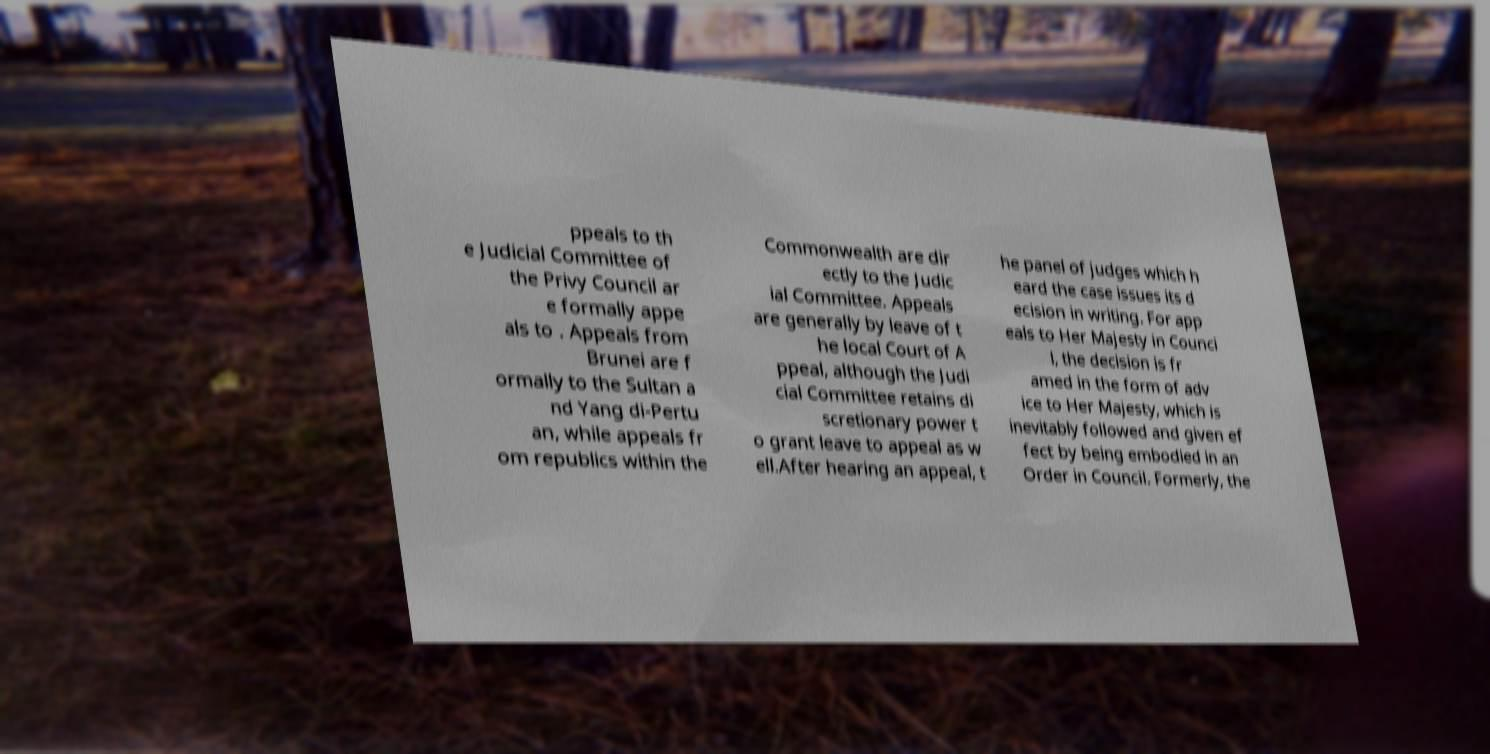I need the written content from this picture converted into text. Can you do that? ppeals to th e Judicial Committee of the Privy Council ar e formally appe als to . Appeals from Brunei are f ormally to the Sultan a nd Yang di-Pertu an, while appeals fr om republics within the Commonwealth are dir ectly to the Judic ial Committee. Appeals are generally by leave of t he local Court of A ppeal, although the Judi cial Committee retains di scretionary power t o grant leave to appeal as w ell.After hearing an appeal, t he panel of judges which h eard the case issues its d ecision in writing. For app eals to Her Majesty in Counci l, the decision is fr amed in the form of adv ice to Her Majesty, which is inevitably followed and given ef fect by being embodied in an Order in Council. Formerly, the 